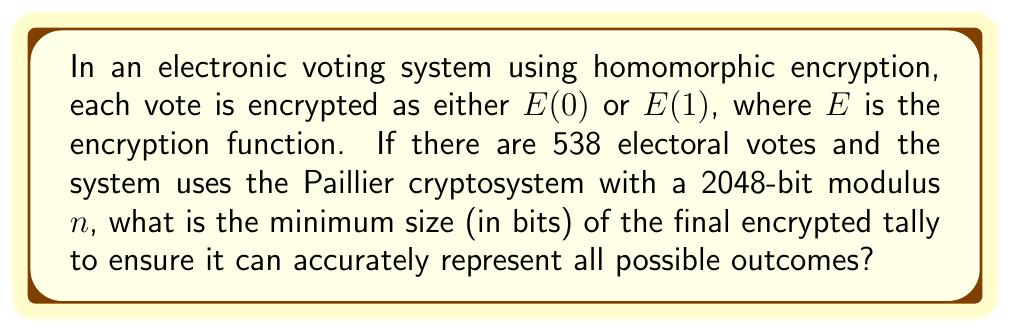Can you solve this math problem? 1. In the Paillier cryptosystem, the ciphertext space is $\mathbb{Z}_{n^2}^*$, where $n$ is the modulus.

2. The size of $n$ is given as 2048 bits, so $n^2$ is 4096 bits.

3. The homomorphic property of Paillier allows us to add encrypted votes:
   $$E(v_1 + v_2) = E(v_1) \cdot E(v_2) \mod n^2$$

4. The maximum possible tally is when all 538 electoral votes are 1:
   $$\text{max tally} = 538$$

5. We need to ensure that $n > 538$ to correctly represent all possible outcomes.

6. Given $n$ is 2048 bits, it's much larger than 538, so this condition is satisfied.

7. The encrypted tally will be a single ciphertext in $\mathbb{Z}_{n^2}^*$, regardless of the number of votes.

8. Therefore, the size of the encrypted tally is always the size of $n^2$, which is 4096 bits.

This size ensures that the encrypted tally can represent all possible outcomes while maintaining the security properties of the Paillier cryptosystem.
Answer: 4096 bits 